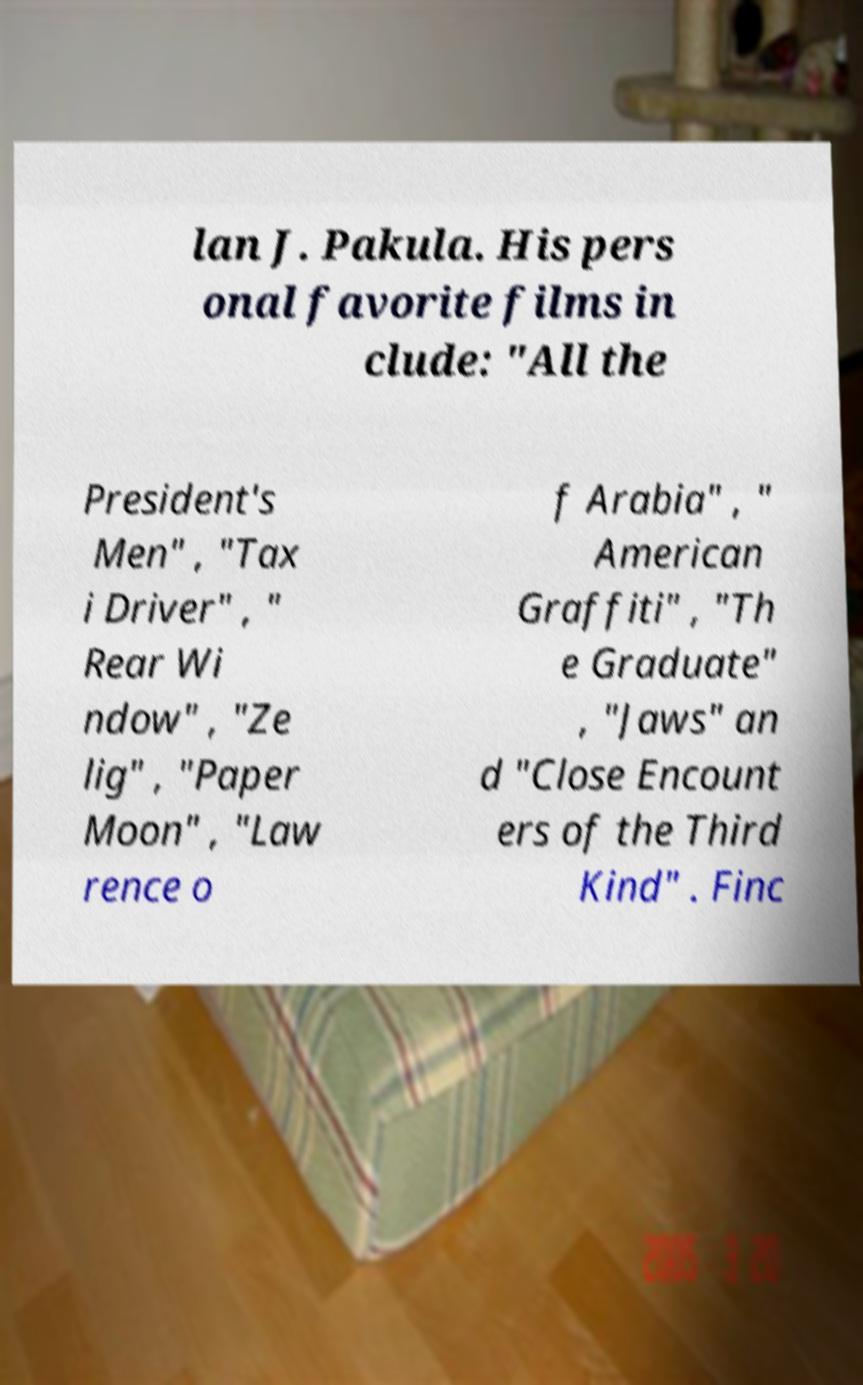I need the written content from this picture converted into text. Can you do that? lan J. Pakula. His pers onal favorite films in clude: "All the President's Men" , "Tax i Driver" , " Rear Wi ndow" , "Ze lig" , "Paper Moon" , "Law rence o f Arabia" , " American Graffiti" , "Th e Graduate" , "Jaws" an d "Close Encount ers of the Third Kind" . Finc 